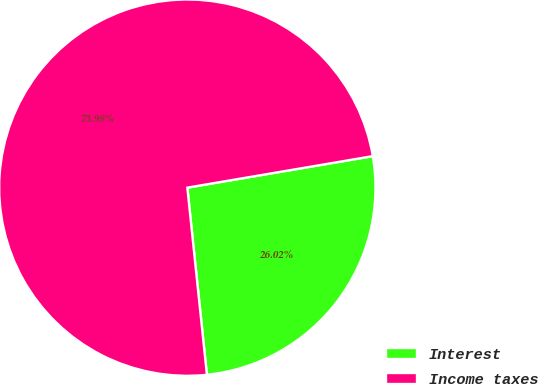<chart> <loc_0><loc_0><loc_500><loc_500><pie_chart><fcel>Interest<fcel>Income taxes<nl><fcel>26.02%<fcel>73.98%<nl></chart> 